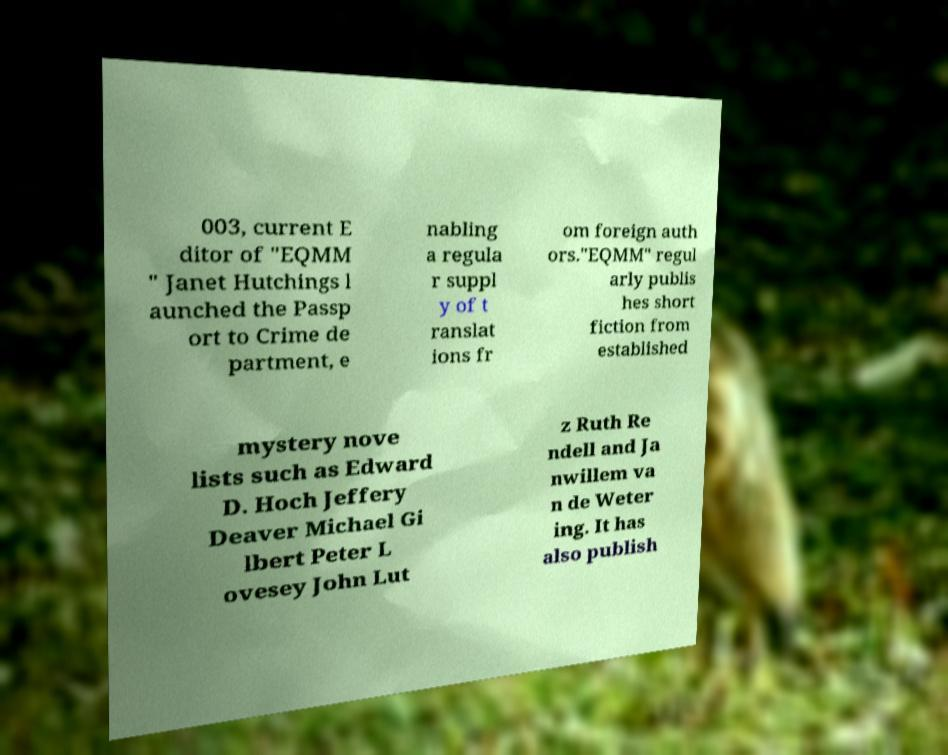Could you extract and type out the text from this image? 003, current E ditor of "EQMM " Janet Hutchings l aunched the Passp ort to Crime de partment, e nabling a regula r suppl y of t ranslat ions fr om foreign auth ors."EQMM" regul arly publis hes short fiction from established mystery nove lists such as Edward D. Hoch Jeffery Deaver Michael Gi lbert Peter L ovesey John Lut z Ruth Re ndell and Ja nwillem va n de Weter ing. It has also publish 